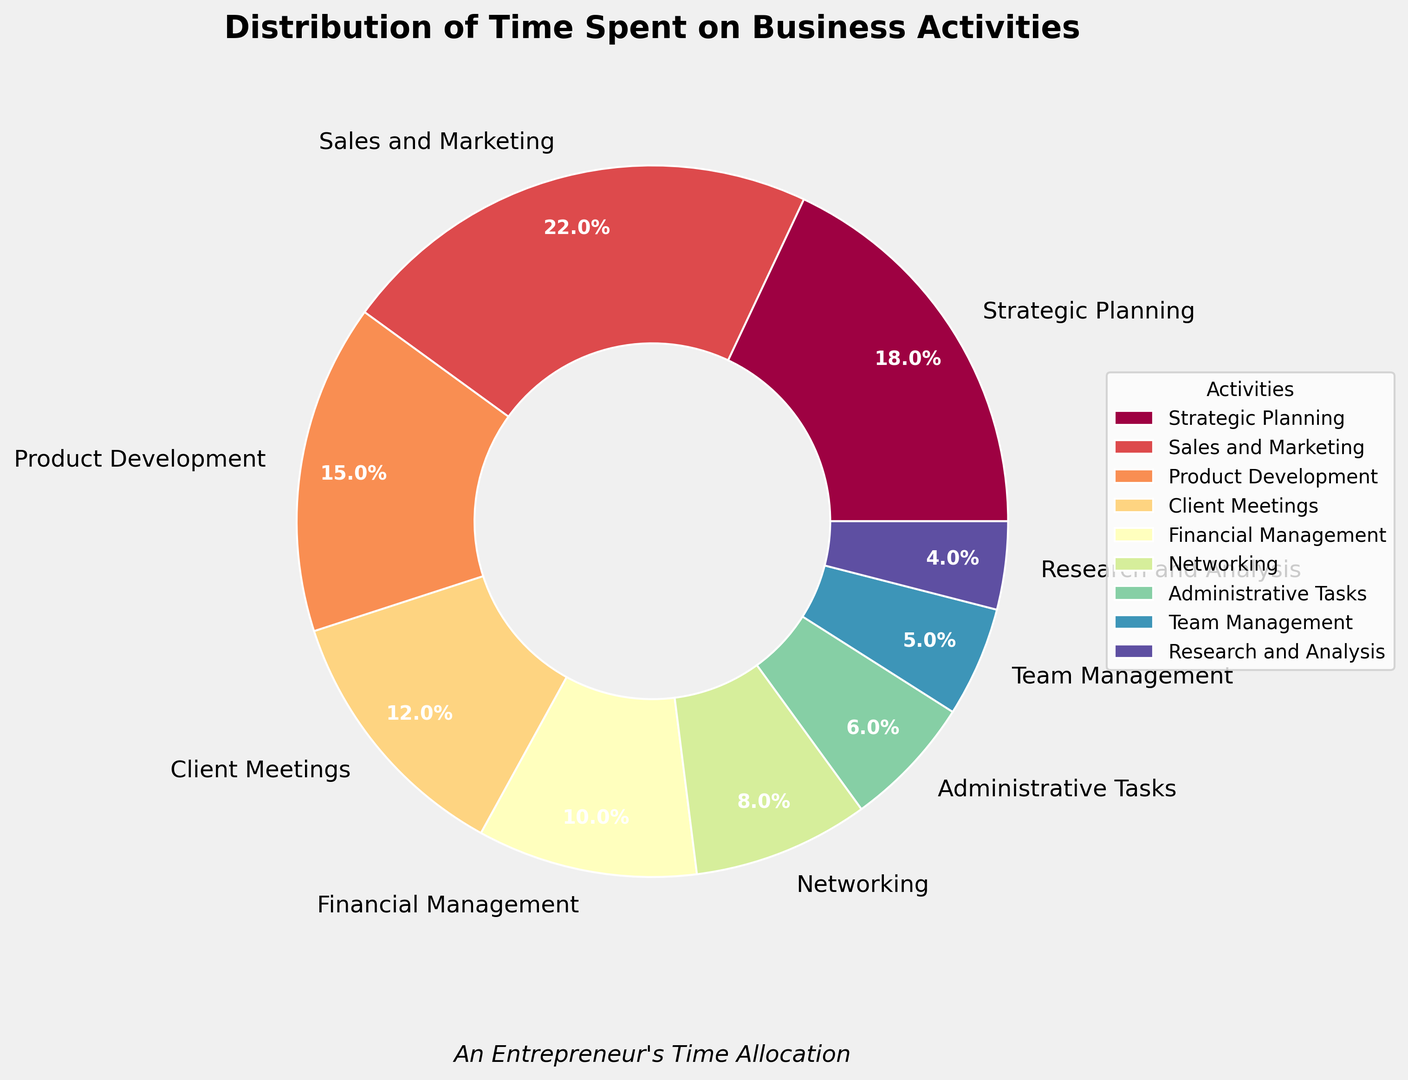what is the total percentage of time spent on Sales and Marketing, and Product Development? Adding the percentages for Sales and Marketing (22) and Product Development (15) gives you the total time spent on these activities. 22 + 15 = 37.
Answer: 37 How many activities have more than 10% allocated time? To answer this, count the number of activities with percentages higher than 10. They are Strategic Planning (18), Sales and Marketing (22), and Product Development (15).
Answer: 3 Which activity has the least allocated time and what percentage is it? The activity with the smallest wedge and corresponding label is Research and Analysis, with 4%.
Answer: Research and Analysis, 4% Is the time spent on Strategic Planning greater than that on Financial Management? Comparing the two percentages, Strategic Planning has 18% and Financial Management has 10%. So, 18 is greater than 10.
Answer: Yes Which activity uses more time: Networking or Administrative Tasks? Looking at the chart, Networking has 8% while Administrative Tasks has 6%. Comparing these two values, 8 is greater than 6.
Answer: Networking If you combine the time spent on Client Meetings and Team Management, what is their total percentage? Adding the percentages for Client Meetings (12) and Team Management (5) gives their combined total. 12 + 5 = 17.
Answer: 17 Among the activities that have less than 10% allocated time, which one has the highest percentage? Look at the activities under 10%: Financial Management (10), Networking (8), Administrative Tasks (6), Team Management (5), and Research and Analysis (4). The highest among these is Financial Management with 10%.
Answer: Financial Management, 10% How much more time is spent on Sales and Marketing compared to Research and Analysis? Subtract the Research and Analysis percentage (4%) from Sales and Marketing (22%). 22 - 4 = 18.
Answer: 18 What is the average percentage of time spent on Strategic Planning, Sales and Marketing, and Client Meetings? Adding the percentages of these activities: 18 (Strategic Planning) + 22 (Sales and Marketing) + 12 (Client Meetings) = 52, then dividing by 3. 52 / 3 ≈ 17.33.
Answer: 17.33 If you sum the time spent on Administrative Tasks, Team Management, and Research and Analysis, what would be the total? Adding their percentages: 6 (Administrative Tasks) + 5 (Team Management) + 4 (Research and Analysis) = 15.
Answer: 15 